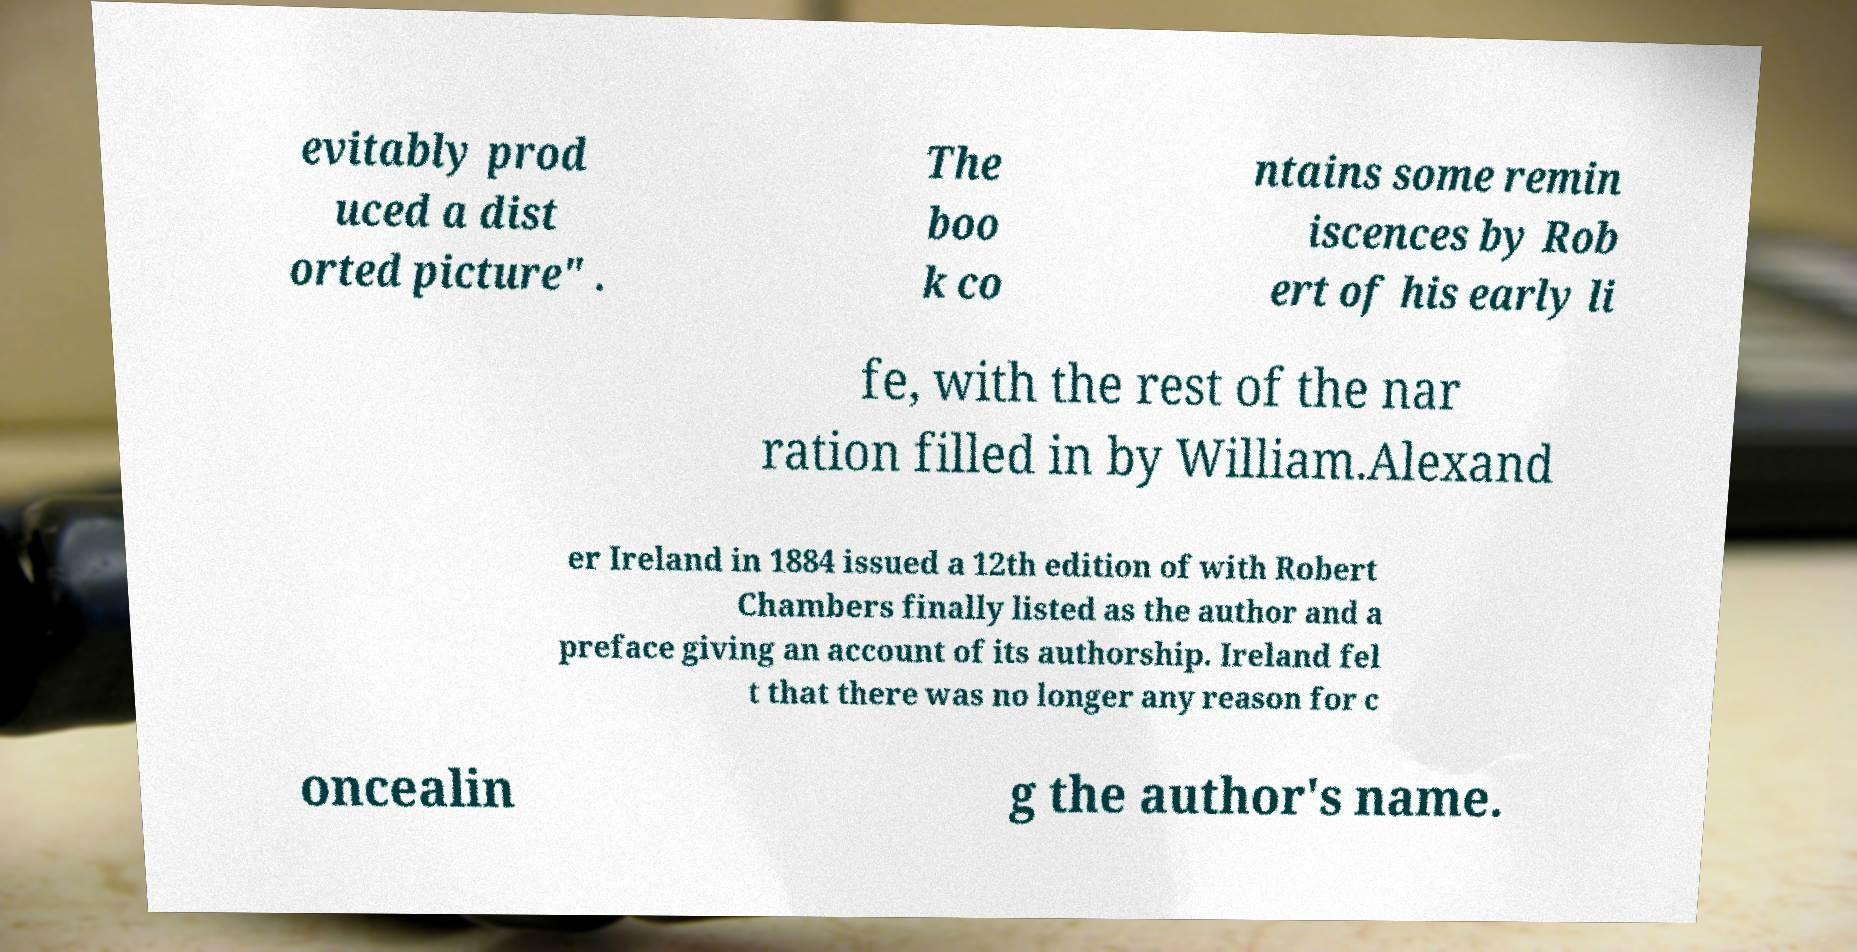What messages or text are displayed in this image? I need them in a readable, typed format. evitably prod uced a dist orted picture" . The boo k co ntains some remin iscences by Rob ert of his early li fe, with the rest of the nar ration filled in by William.Alexand er Ireland in 1884 issued a 12th edition of with Robert Chambers finally listed as the author and a preface giving an account of its authorship. Ireland fel t that there was no longer any reason for c oncealin g the author's name. 